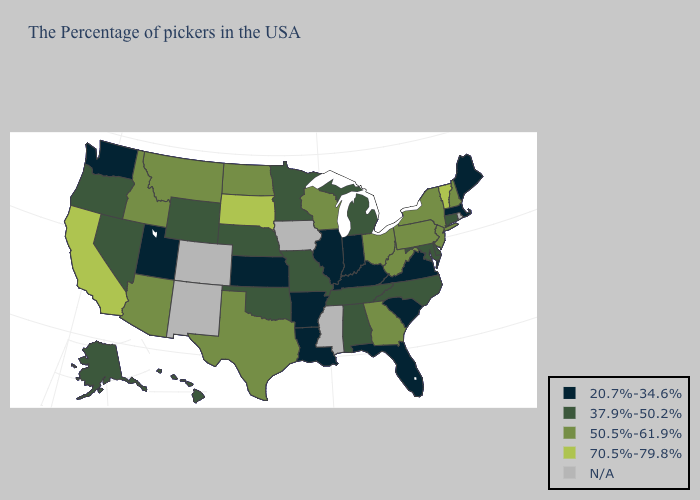What is the highest value in the USA?
Quick response, please. 70.5%-79.8%. What is the value of Kansas?
Short answer required. 20.7%-34.6%. Among the states that border North Dakota , does South Dakota have the highest value?
Answer briefly. Yes. Name the states that have a value in the range N/A?
Answer briefly. Rhode Island, Mississippi, Iowa, Colorado, New Mexico. Name the states that have a value in the range N/A?
Write a very short answer. Rhode Island, Mississippi, Iowa, Colorado, New Mexico. What is the value of New York?
Short answer required. 50.5%-61.9%. Which states have the lowest value in the South?
Answer briefly. Virginia, South Carolina, Florida, Kentucky, Louisiana, Arkansas. Does the map have missing data?
Quick response, please. Yes. Is the legend a continuous bar?
Keep it brief. No. Does the map have missing data?
Keep it brief. Yes. Does Florida have the highest value in the USA?
Answer briefly. No. Does Vermont have the highest value in the USA?
Short answer required. Yes. What is the value of Tennessee?
Answer briefly. 37.9%-50.2%. Name the states that have a value in the range 70.5%-79.8%?
Be succinct. Vermont, South Dakota, California. 